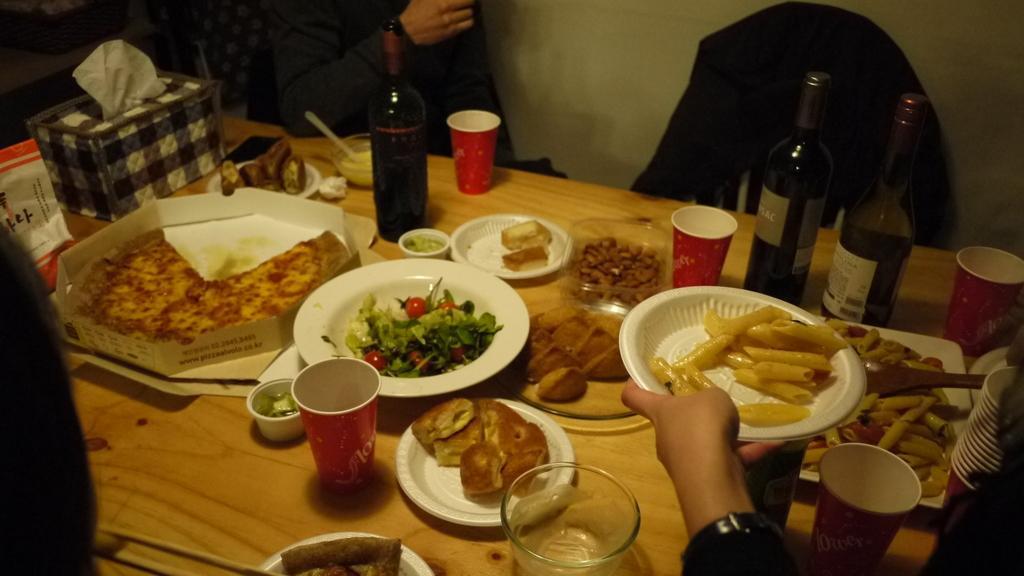Please provide a concise description of this image. Different type of dishes with champagne bottles and few cookies are on table. With few people around it. 